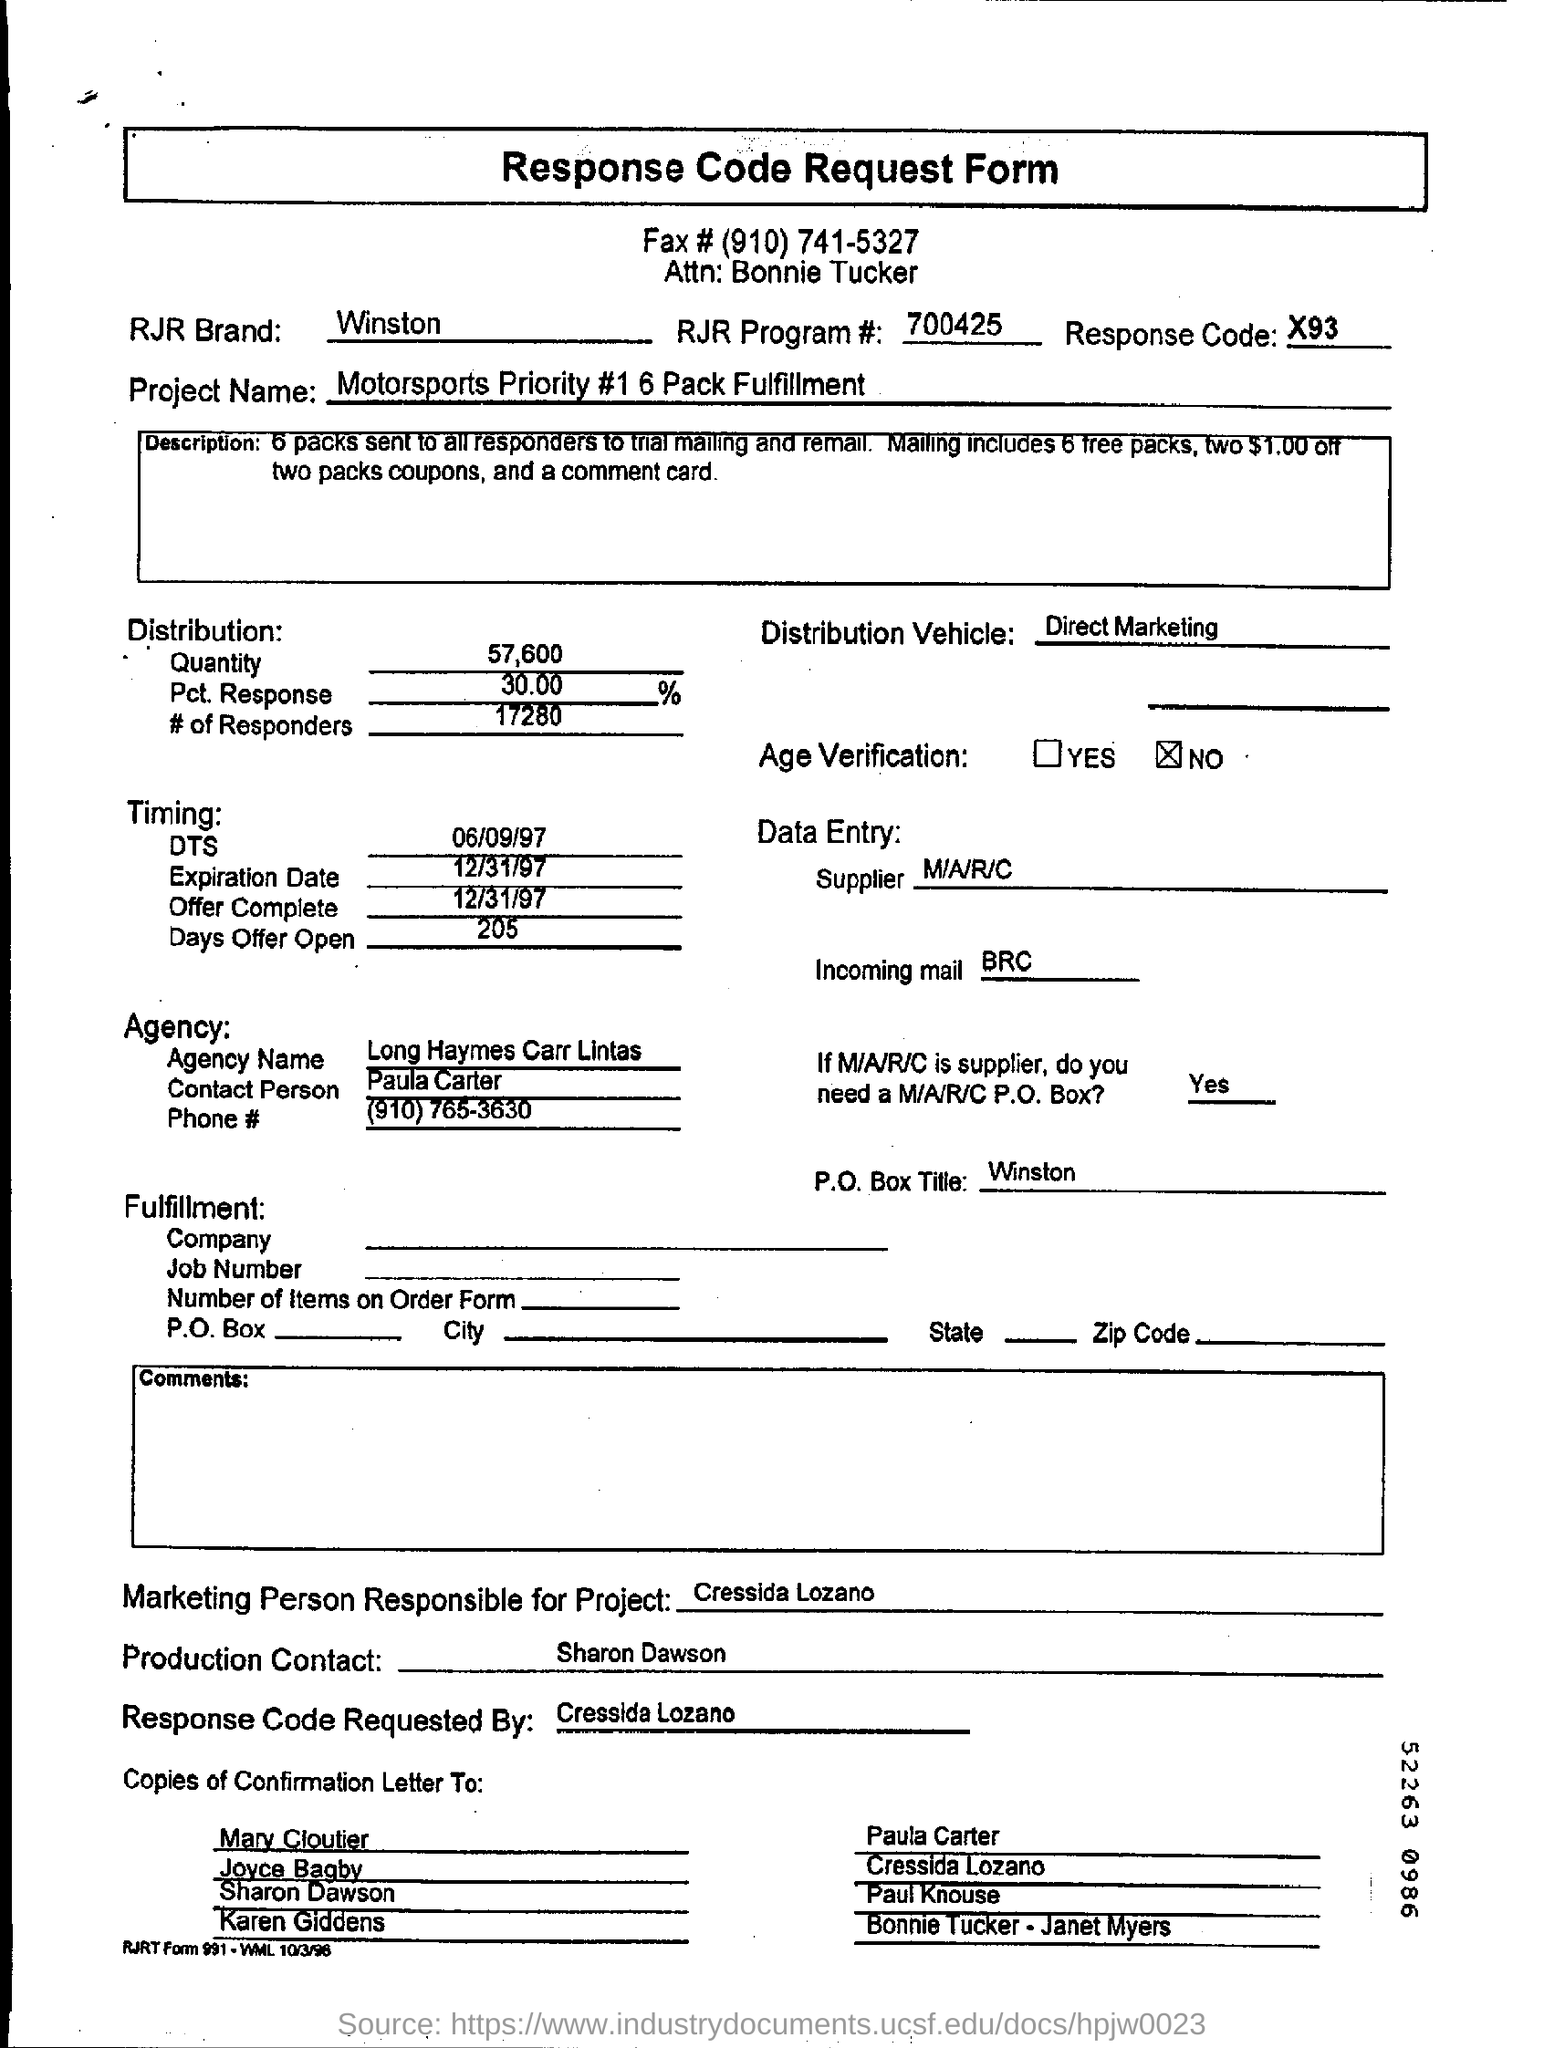Mention a couple of crucial points in this snapshot. The RJR Brand is Winston. There were 17,280 responders to the survey. The recipient of the letter addressed to 'Attn: Bonnie Tucker'" is Bonnie Tucker. The RJR Program number is 700425. The document is titled 'Response Code Request Form.' 